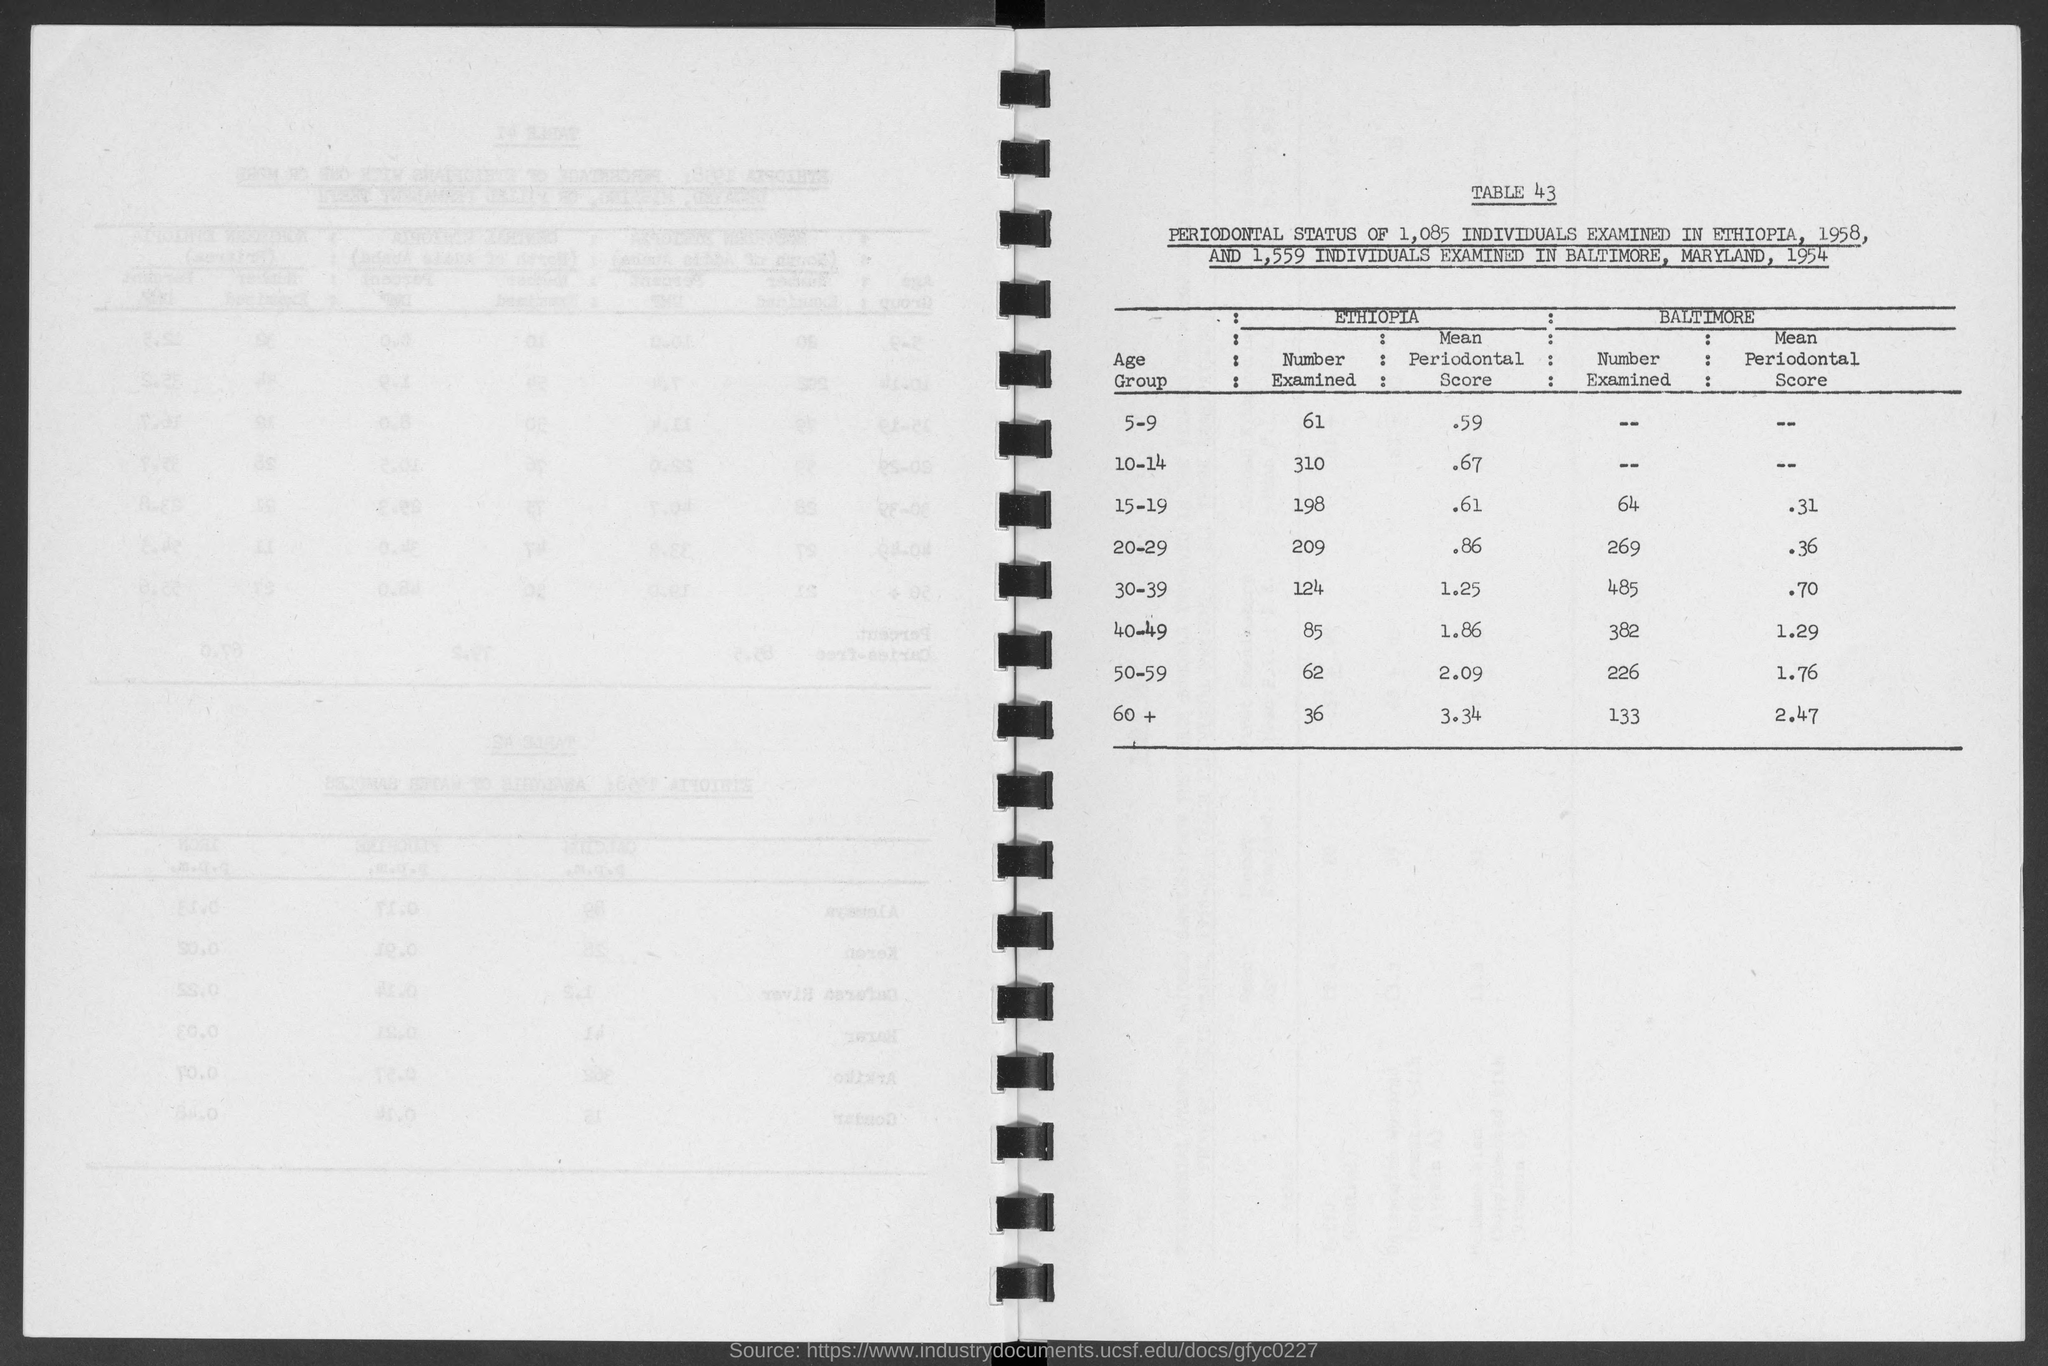Point out several critical features in this image. A study was conducted in Baltimore to examine the number of individuals in the age group of 15-19. The result of the study showed that 64% of the examined individuals belonged to this age group. In Ethiopia, the number of children aged 5-9 who have been examined is 61. In Ethiopia, the number of examinations conducted for the age group of 50-59 is 62. In Ethiopia, an examination of the number of individuals in the age group of 40-49 was conducted and the result showed that 85 was the number. In Ethiopia, the number of examinations conducted for the age group of 30-39 is 124. 